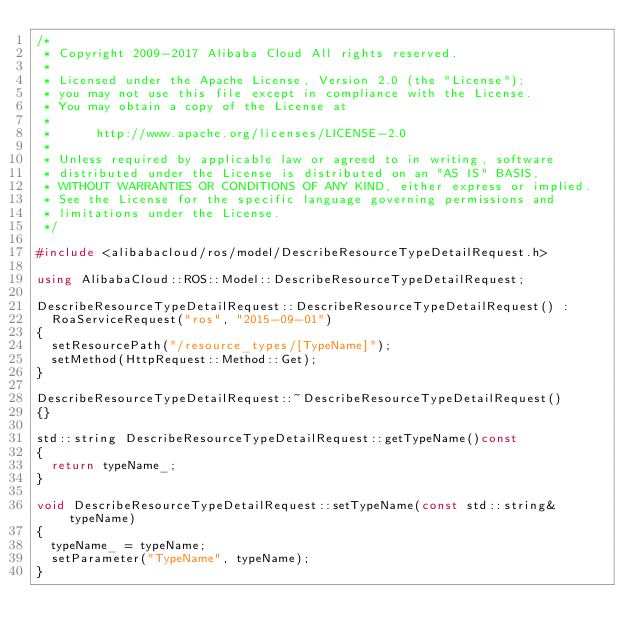Convert code to text. <code><loc_0><loc_0><loc_500><loc_500><_C++_>/*
 * Copyright 2009-2017 Alibaba Cloud All rights reserved.
 * 
 * Licensed under the Apache License, Version 2.0 (the "License");
 * you may not use this file except in compliance with the License.
 * You may obtain a copy of the License at
 * 
 *      http://www.apache.org/licenses/LICENSE-2.0
 * 
 * Unless required by applicable law or agreed to in writing, software
 * distributed under the License is distributed on an "AS IS" BASIS,
 * WITHOUT WARRANTIES OR CONDITIONS OF ANY KIND, either express or implied.
 * See the License for the specific language governing permissions and
 * limitations under the License.
 */

#include <alibabacloud/ros/model/DescribeResourceTypeDetailRequest.h>

using AlibabaCloud::ROS::Model::DescribeResourceTypeDetailRequest;

DescribeResourceTypeDetailRequest::DescribeResourceTypeDetailRequest() :
	RoaServiceRequest("ros", "2015-09-01")
{
	setResourcePath("/resource_types/[TypeName]");
	setMethod(HttpRequest::Method::Get);
}

DescribeResourceTypeDetailRequest::~DescribeResourceTypeDetailRequest()
{}

std::string DescribeResourceTypeDetailRequest::getTypeName()const
{
	return typeName_;
}

void DescribeResourceTypeDetailRequest::setTypeName(const std::string& typeName)
{
	typeName_ = typeName;
	setParameter("TypeName", typeName);
}

</code> 